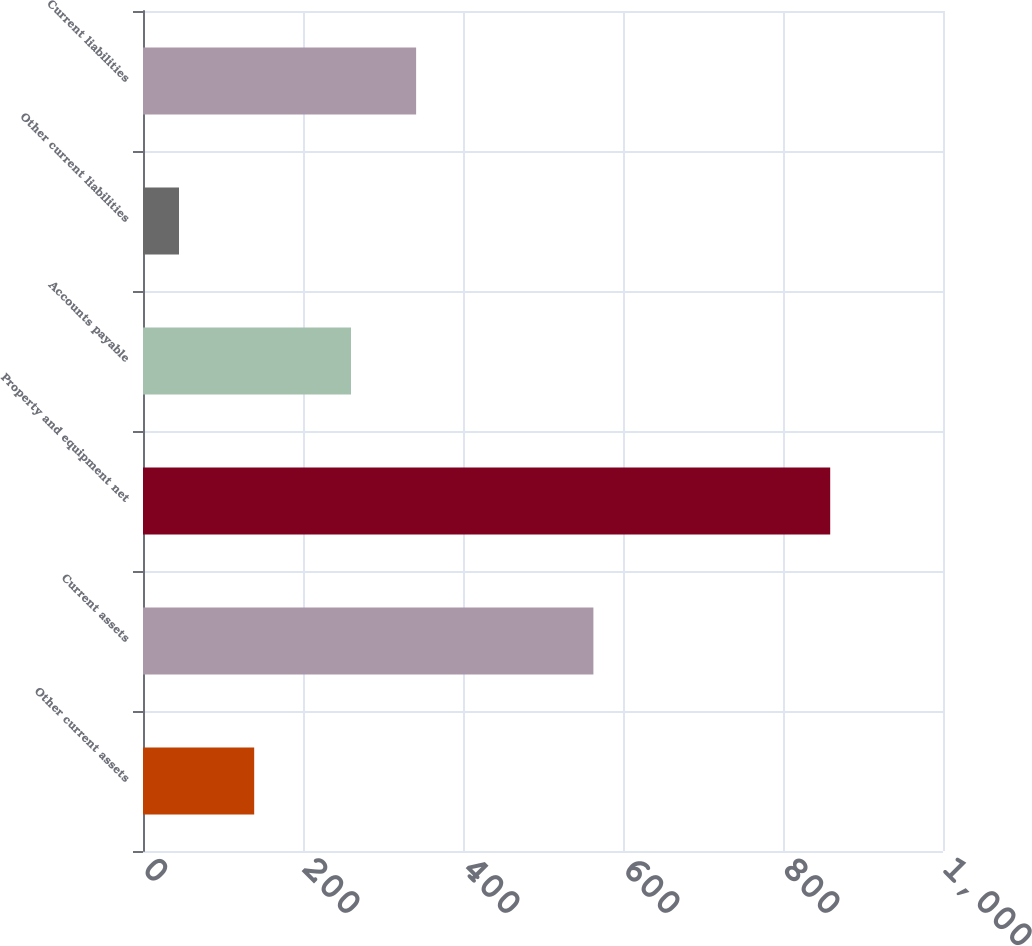<chart> <loc_0><loc_0><loc_500><loc_500><bar_chart><fcel>Other current assets<fcel>Current assets<fcel>Property and equipment net<fcel>Accounts payable<fcel>Other current liabilities<fcel>Current liabilities<nl><fcel>139<fcel>563<fcel>859<fcel>260<fcel>45<fcel>341.4<nl></chart> 